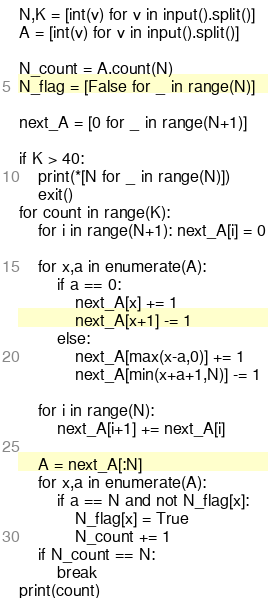<code> <loc_0><loc_0><loc_500><loc_500><_Python_>N,K = [int(v) for v in input().split()]
A = [int(v) for v in input().split()]

N_count = A.count(N)
N_flag = [False for _ in range(N)]

next_A = [0 for _ in range(N+1)]

if K > 40:
    print(*[N for _ in range(N)])
    exit()
for count in range(K):
    for i in range(N+1): next_A[i] = 0

    for x,a in enumerate(A):
        if a == 0:
            next_A[x] += 1
            next_A[x+1] -= 1
        else:
            next_A[max(x-a,0)] += 1
            next_A[min(x+a+1,N)] -= 1

    for i in range(N):
        next_A[i+1] += next_A[i]

    A = next_A[:N]
    for x,a in enumerate(A):
        if a == N and not N_flag[x]:
            N_flag[x] = True
            N_count += 1
    if N_count == N:
        break
print(count)
</code> 